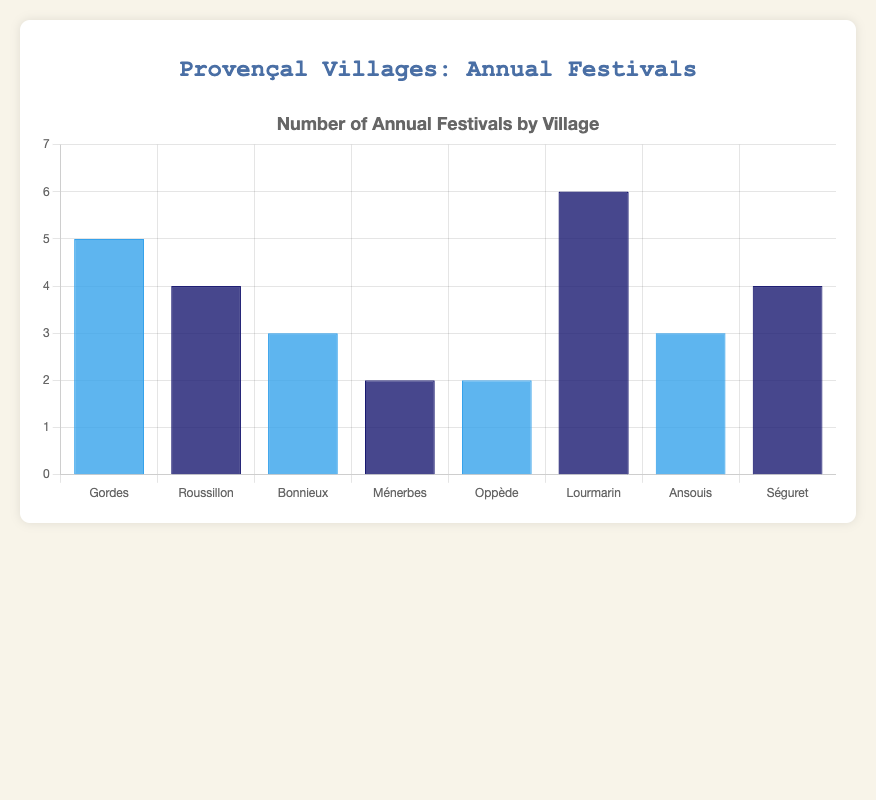Which village has the highest number of annual festivals? By looking at the height of the bars, we can see that the tallest bar is for Lourmarin, indicating it has the highest number of festivals.
Answer: Lourmarin Which two villages have the same number of annual festivals? We need to identify bars that have the same height. Ménerbes and Oppède both have bars of equal height.
Answer: Ménerbes, Oppède How many more festivals does Lourmarin have compared to Bonnieux? Lourmarin has 6 festivals, and Bonnieux has 3. Subtract Bonnieux's festivals from Lourmarin's: 6 - 3 = 3.
Answer: 3 Which village has more annual festivals: Roussillon or Séguret? By comparing the heights of the bars for Roussillon and Séguret, Roussillon has slightly fewer festivals than Séguret.
Answer: Séguret What’s the combined number of festivals for Gordes and Roussillon? Gordes has 5 festivals, and Roussillon has 4. Add these together: 5 + 4 = 9.
Answer: 9 List the villages that have fewer than 3 annual festivals. We need to identify bars whose height is below the value of 3 festivals. Ménerbes and Oppède both have fewer than 3 festivals.
Answer: Ménerbes, Oppède What's the average number of festivals across all the villages? Sum the number of festivals in each village: 5 + 4 + 3 + 2 + 2 + 6 + 3 + 4 = 29. Divide by the number of villages (8): 29 / 8 = 3.625.
Answer: 3.625 Which village has one more festival than Ansouis? Ansouis has 3 festivals. The village with 4 festivals (3 + 1) is Séguret.
Answer: Séguret How many villages have more than 4 annual festivals? Count the bars with heights greater than 4. Only Gordes and Lourmarin have more than 4 festivals.
Answer: 2 In terms of bar color, which type (blue or dark blue) represents Lori’s Lourmarin? By examining the visually distinct color of Lourmarin's bar, it is dark blue.
Answer: dark blue 